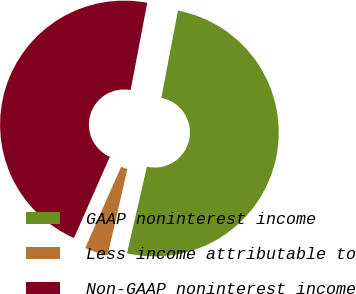Convert chart. <chart><loc_0><loc_0><loc_500><loc_500><pie_chart><fcel>GAAP noninterest income<fcel>Less income attributable to<fcel>Non-GAAP noninterest income<nl><fcel>50.59%<fcel>3.03%<fcel>46.38%<nl></chart> 